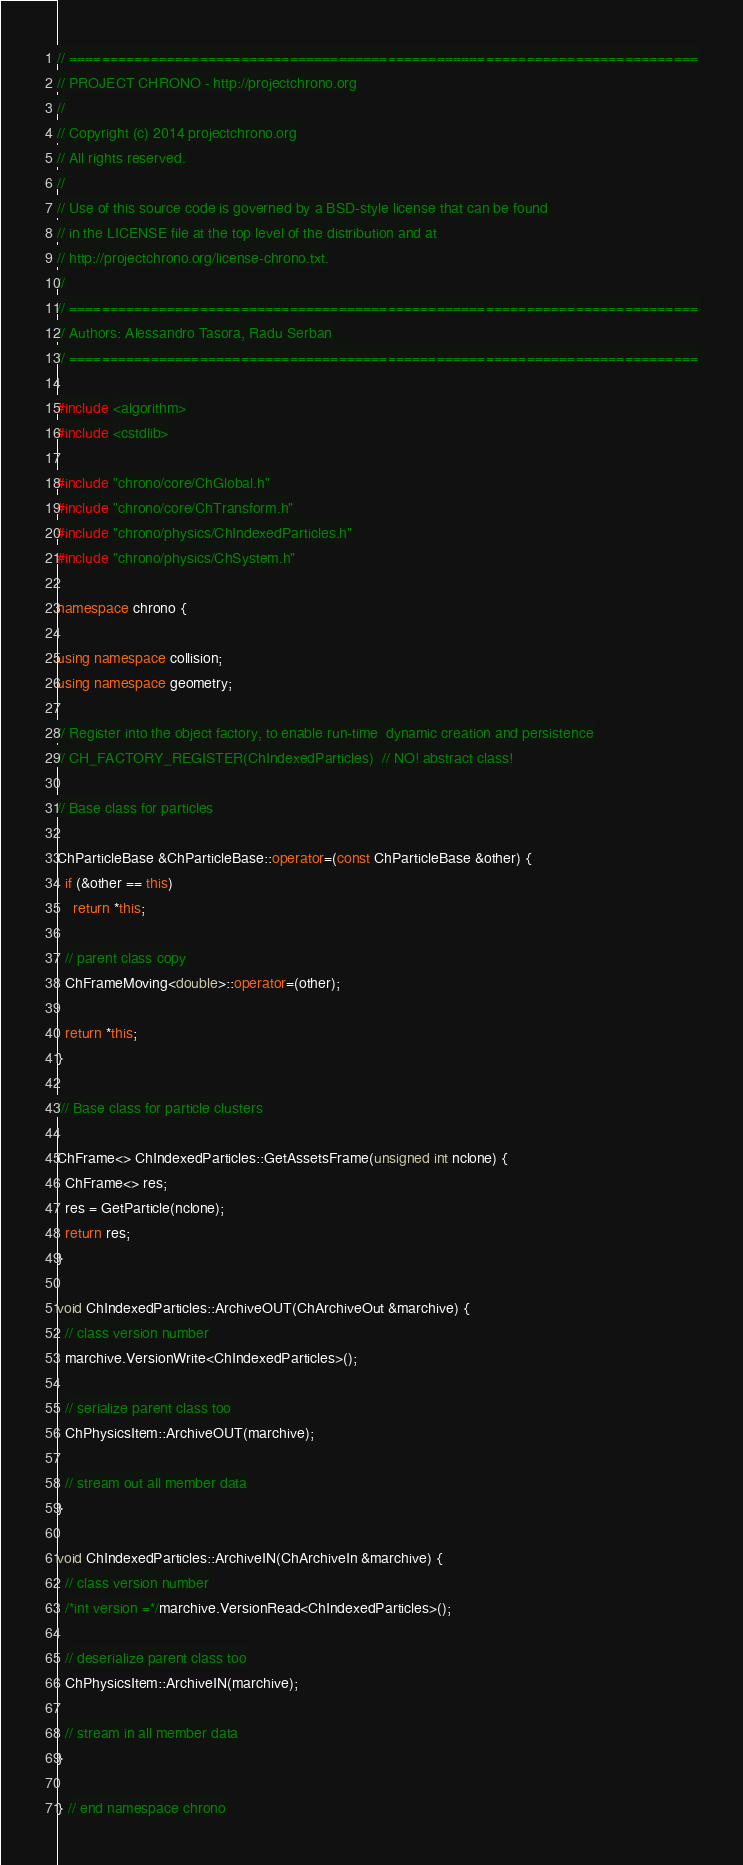Convert code to text. <code><loc_0><loc_0><loc_500><loc_500><_C++_>// =============================================================================
// PROJECT CHRONO - http://projectchrono.org
//
// Copyright (c) 2014 projectchrono.org
// All rights reserved.
//
// Use of this source code is governed by a BSD-style license that can be found
// in the LICENSE file at the top level of the distribution and at
// http://projectchrono.org/license-chrono.txt.
//
// =============================================================================
// Authors: Alessandro Tasora, Radu Serban
// =============================================================================

#include <algorithm>
#include <cstdlib>

#include "chrono/core/ChGlobal.h"
#include "chrono/core/ChTransform.h"
#include "chrono/physics/ChIndexedParticles.h"
#include "chrono/physics/ChSystem.h"

namespace chrono {

using namespace collision;
using namespace geometry;

// Register into the object factory, to enable run-time  dynamic creation and persistence
// CH_FACTORY_REGISTER(ChIndexedParticles)  // NO! abstract class!

// Base class for particles

ChParticleBase &ChParticleBase::operator=(const ChParticleBase &other) {
  if (&other == this)
    return *this;

  // parent class copy
  ChFrameMoving<double>::operator=(other);

  return *this;
}

/// Base class for particle clusters

ChFrame<> ChIndexedParticles::GetAssetsFrame(unsigned int nclone) {
  ChFrame<> res;
  res = GetParticle(nclone);
  return res;
}

void ChIndexedParticles::ArchiveOUT(ChArchiveOut &marchive) {
  // class version number
  marchive.VersionWrite<ChIndexedParticles>();

  // serialize parent class too
  ChPhysicsItem::ArchiveOUT(marchive);

  // stream out all member data
}

void ChIndexedParticles::ArchiveIN(ChArchiveIn &marchive) {
  // class version number
  /*int version =*/marchive.VersionRead<ChIndexedParticles>();

  // deserialize parent class too
  ChPhysicsItem::ArchiveIN(marchive);

  // stream in all member data
}

} // end namespace chrono
</code> 